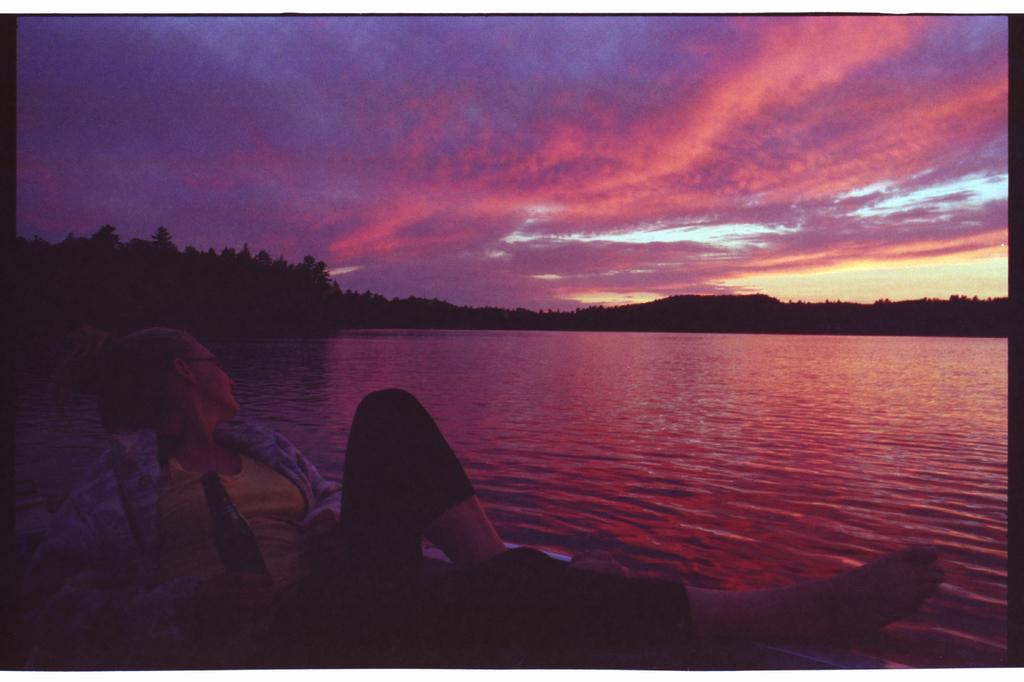Who is present in the image? There is a woman in the picture. What is the woman holding in the image? The woman is holding a wine bottle. What is the woman sitting on in the image? The woman is sitting on an object on the water. What can be seen in the background of the image? There are trees in the background of the image. How would you describe the sky in the image? The sky is cloudy in the image. What is the woman's aunt saying about her wealth in the image? There is no mention of the woman's aunt or wealth in the image. Can you see any frogs in the image? There are no frogs present in the image. 